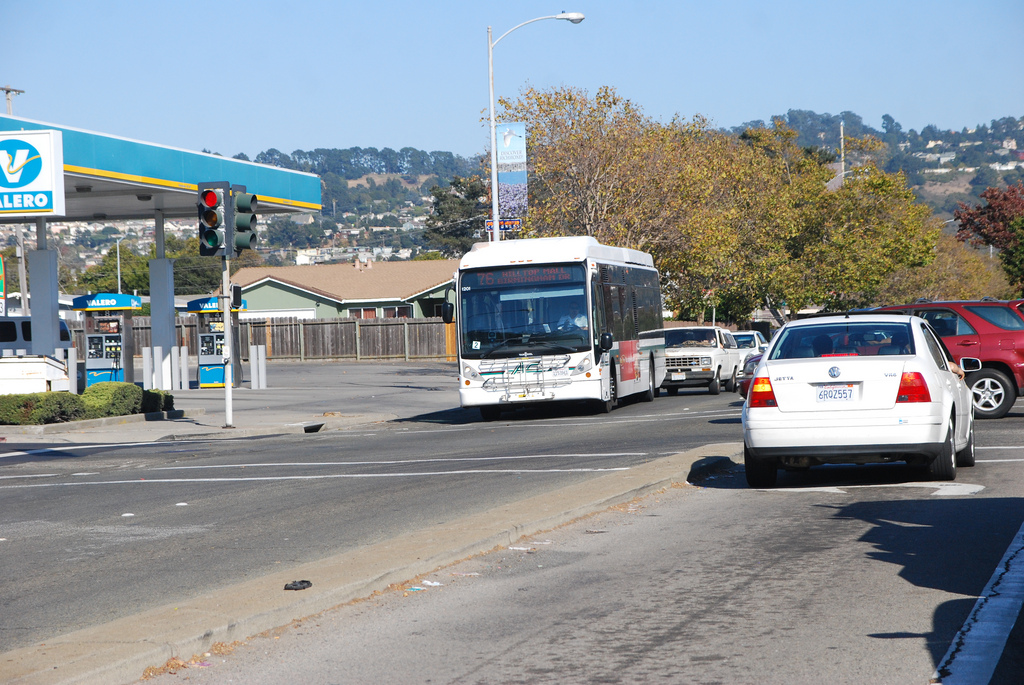Is the person to the right or to the left of the wood fence? The pedestrian is walking on the sidewalk to the right of the wooden fence, in the direction opposite to the vehicles on the road. 